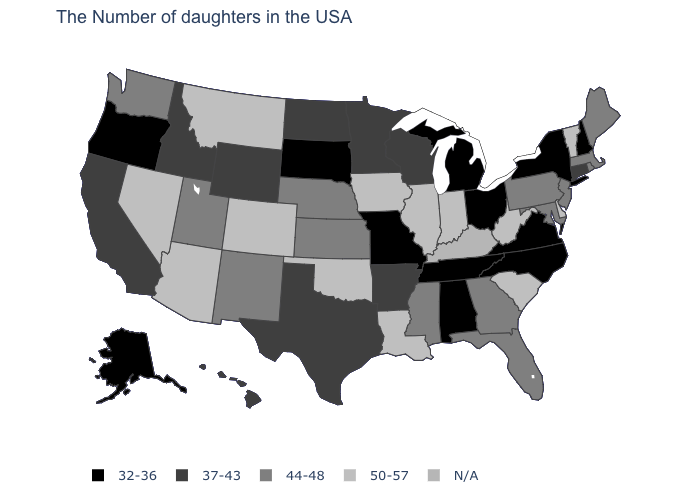Which states hav the highest value in the West?
Answer briefly. Colorado, Montana, Arizona, Nevada. Among the states that border Rhode Island , which have the highest value?
Keep it brief. Massachusetts. What is the value of New Mexico?
Answer briefly. 44-48. Name the states that have a value in the range 44-48?
Keep it brief. Maine, Massachusetts, Rhode Island, New Jersey, Maryland, Pennsylvania, Florida, Georgia, Mississippi, Kansas, Nebraska, New Mexico, Utah, Washington. Name the states that have a value in the range 37-43?
Give a very brief answer. Connecticut, Wisconsin, Arkansas, Minnesota, Texas, North Dakota, Wyoming, Idaho, California, Hawaii. Which states hav the highest value in the MidWest?
Keep it brief. Indiana, Illinois, Iowa. Which states hav the highest value in the Northeast?
Be succinct. Vermont. What is the lowest value in states that border Vermont?
Keep it brief. 32-36. Name the states that have a value in the range 44-48?
Answer briefly. Maine, Massachusetts, Rhode Island, New Jersey, Maryland, Pennsylvania, Florida, Georgia, Mississippi, Kansas, Nebraska, New Mexico, Utah, Washington. Name the states that have a value in the range 37-43?
Be succinct. Connecticut, Wisconsin, Arkansas, Minnesota, Texas, North Dakota, Wyoming, Idaho, California, Hawaii. What is the value of Ohio?
Give a very brief answer. 32-36. 